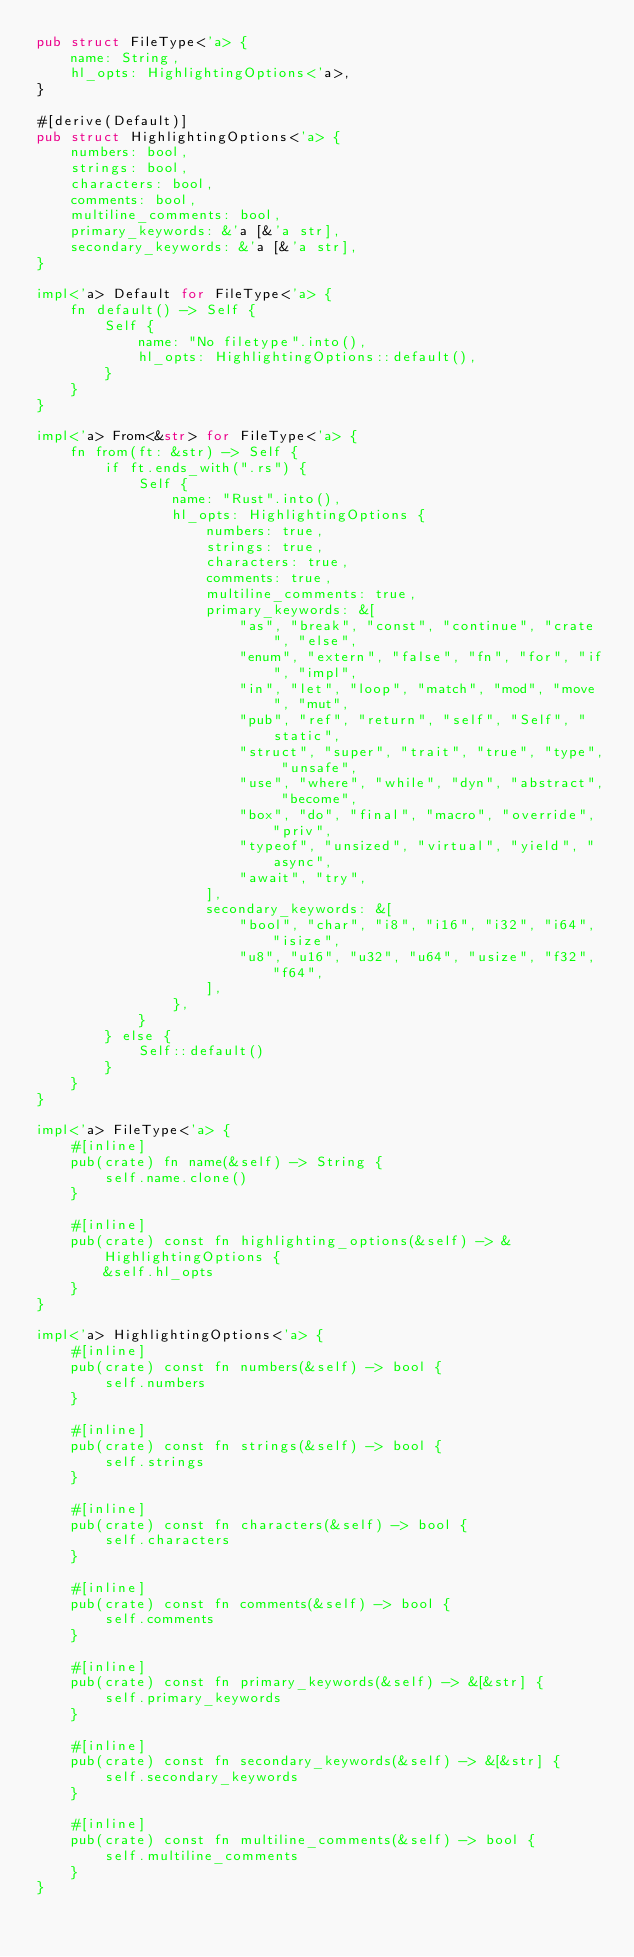Convert code to text. <code><loc_0><loc_0><loc_500><loc_500><_Rust_>pub struct FileType<'a> {
    name: String,
    hl_opts: HighlightingOptions<'a>,
}

#[derive(Default)]
pub struct HighlightingOptions<'a> {
    numbers: bool,
    strings: bool,
    characters: bool,
    comments: bool,
    multiline_comments: bool,
    primary_keywords: &'a [&'a str],
    secondary_keywords: &'a [&'a str],
}

impl<'a> Default for FileType<'a> {
    fn default() -> Self {
        Self {
            name: "No filetype".into(),
            hl_opts: HighlightingOptions::default(),
        }
    }
}

impl<'a> From<&str> for FileType<'a> {
    fn from(ft: &str) -> Self {
        if ft.ends_with(".rs") {
            Self {
                name: "Rust".into(),
                hl_opts: HighlightingOptions {
                    numbers: true,
                    strings: true,
                    characters: true,
                    comments: true,
                    multiline_comments: true,
                    primary_keywords: &[
                        "as", "break", "const", "continue", "crate", "else",
                        "enum", "extern", "false", "fn", "for", "if", "impl",
                        "in", "let", "loop", "match", "mod", "move", "mut",
                        "pub", "ref", "return", "self", "Self", "static",
                        "struct", "super", "trait", "true", "type", "unsafe",
                        "use", "where", "while", "dyn", "abstract", "become",
                        "box", "do", "final", "macro", "override", "priv",
                        "typeof", "unsized", "virtual", "yield", "async",
                        "await", "try",
                    ],
                    secondary_keywords: &[
                        "bool", "char", "i8", "i16", "i32", "i64", "isize",
                        "u8", "u16", "u32", "u64", "usize", "f32", "f64",
                    ],
                },
            }
        } else {
            Self::default()
        }
    }
}

impl<'a> FileType<'a> {
    #[inline]
    pub(crate) fn name(&self) -> String {
        self.name.clone()
    }

    #[inline]
    pub(crate) const fn highlighting_options(&self) -> &HighlightingOptions {
        &self.hl_opts
    }
}

impl<'a> HighlightingOptions<'a> {
    #[inline]
    pub(crate) const fn numbers(&self) -> bool {
        self.numbers
    }

    #[inline]
    pub(crate) const fn strings(&self) -> bool {
        self.strings
    }

    #[inline]
    pub(crate) const fn characters(&self) -> bool {
        self.characters
    }

    #[inline]
    pub(crate) const fn comments(&self) -> bool {
        self.comments
    }

    #[inline]
    pub(crate) const fn primary_keywords(&self) -> &[&str] {
        self.primary_keywords
    }

    #[inline]
    pub(crate) const fn secondary_keywords(&self) -> &[&str] {
        self.secondary_keywords
    }

    #[inline]
    pub(crate) const fn multiline_comments(&self) -> bool {
        self.multiline_comments
    }
}
</code> 